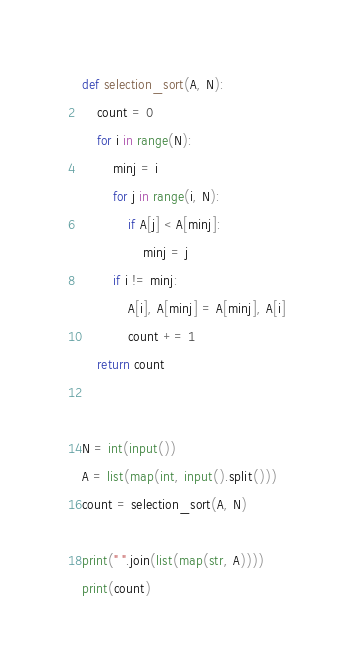<code> <loc_0><loc_0><loc_500><loc_500><_Python_>def selection_sort(A, N):
    count = 0
    for i in range(N):
        minj = i
        for j in range(i, N):
            if A[j] < A[minj]:
                minj = j
        if i != minj:
            A[i], A[minj] = A[minj], A[i]
            count += 1
    return count


N = int(input())
A = list(map(int, input().split()))
count = selection_sort(A, N)

print(" ".join(list(map(str, A))))
print(count)

</code> 